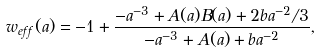Convert formula to latex. <formula><loc_0><loc_0><loc_500><loc_500>w _ { e f f } ( a ) = - 1 + \frac { - a ^ { - 3 } + A ( a ) B ( a ) + 2 b a ^ { - 2 } / 3 } { - a ^ { - 3 } + A ( a ) + b a ^ { - 2 } } ,</formula> 